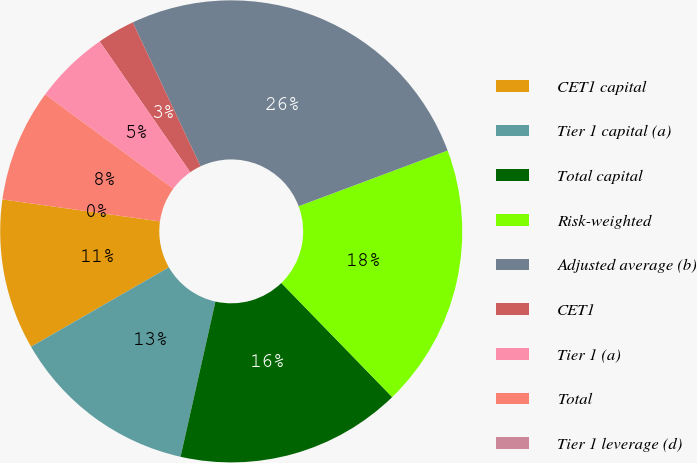<chart> <loc_0><loc_0><loc_500><loc_500><pie_chart><fcel>CET1 capital<fcel>Tier 1 capital (a)<fcel>Total capital<fcel>Risk-weighted<fcel>Adjusted average (b)<fcel>CET1<fcel>Tier 1 (a)<fcel>Total<fcel>Tier 1 leverage (d)<nl><fcel>10.53%<fcel>13.16%<fcel>15.79%<fcel>18.42%<fcel>26.32%<fcel>2.63%<fcel>5.26%<fcel>7.89%<fcel>0.0%<nl></chart> 